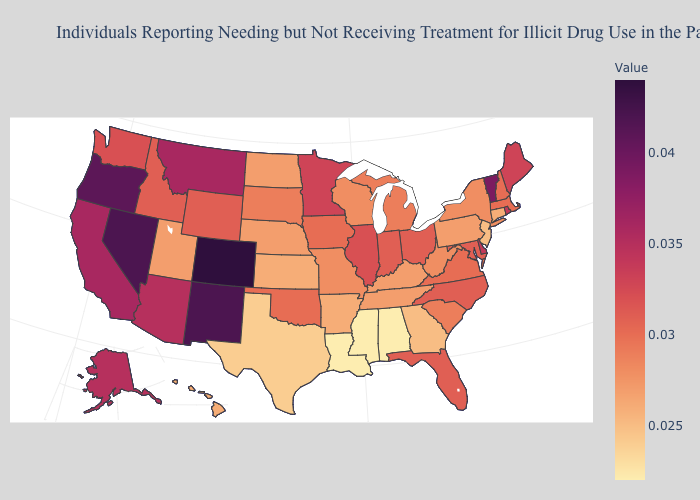Does Colorado have the highest value in the USA?
Keep it brief. Yes. Does North Dakota have a lower value than Indiana?
Concise answer only. Yes. Which states have the lowest value in the USA?
Write a very short answer. Alabama, Louisiana, Mississippi. Which states have the lowest value in the West?
Quick response, please. Hawaii. Does North Carolina have the lowest value in the South?
Give a very brief answer. No. Does Oklahoma have the highest value in the South?
Quick response, please. No. 